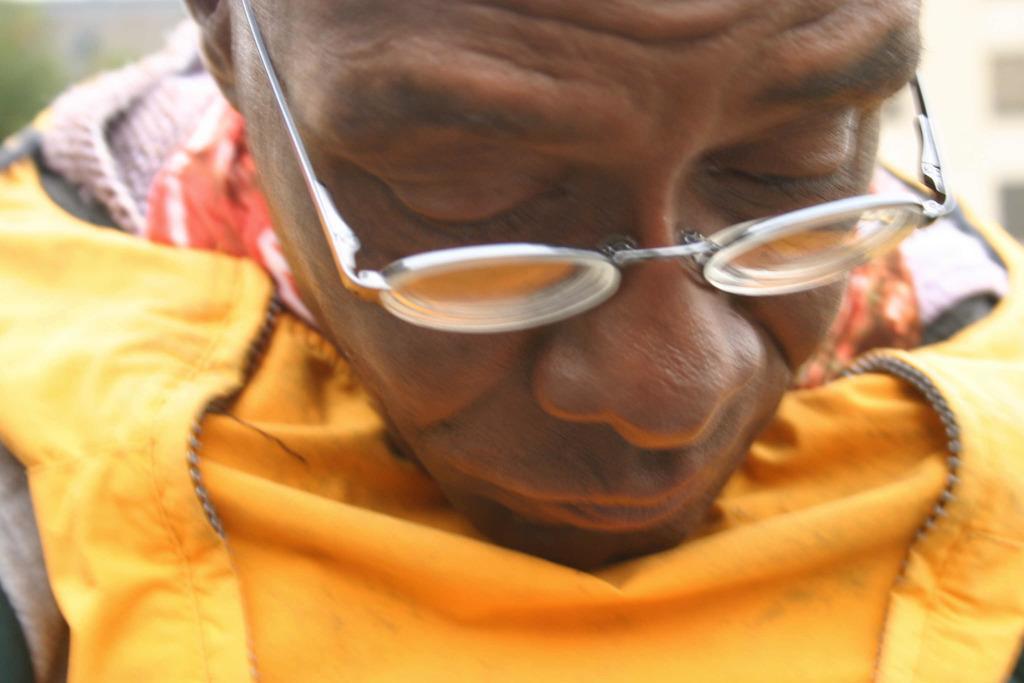Could you give a brief overview of what you see in this image? In this image there is a man, he is wearing a spectacle, there is dress towards the bottom of the image, the background of the image is blurred. 